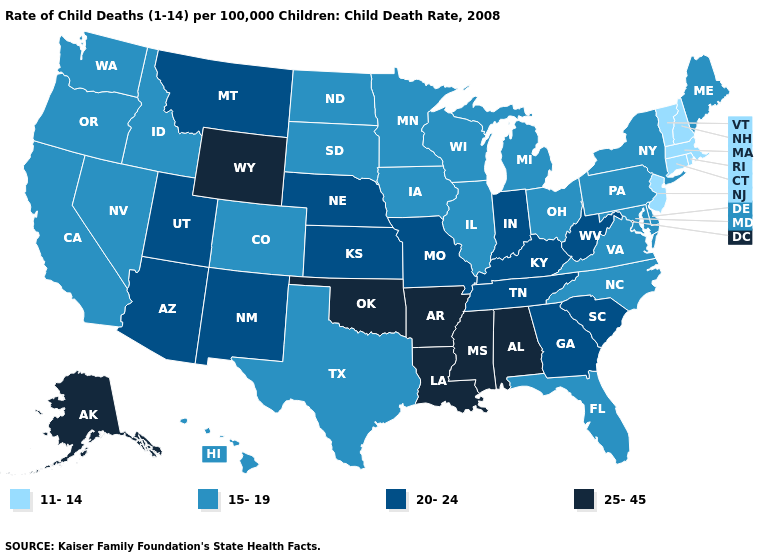Name the states that have a value in the range 15-19?
Keep it brief. California, Colorado, Delaware, Florida, Hawaii, Idaho, Illinois, Iowa, Maine, Maryland, Michigan, Minnesota, Nevada, New York, North Carolina, North Dakota, Ohio, Oregon, Pennsylvania, South Dakota, Texas, Virginia, Washington, Wisconsin. Which states have the lowest value in the South?
Short answer required. Delaware, Florida, Maryland, North Carolina, Texas, Virginia. Name the states that have a value in the range 20-24?
Keep it brief. Arizona, Georgia, Indiana, Kansas, Kentucky, Missouri, Montana, Nebraska, New Mexico, South Carolina, Tennessee, Utah, West Virginia. What is the lowest value in the MidWest?
Answer briefly. 15-19. What is the value of Mississippi?
Concise answer only. 25-45. Is the legend a continuous bar?
Be succinct. No. Does Arkansas have a lower value than Utah?
Concise answer only. No. Among the states that border Ohio , which have the lowest value?
Keep it brief. Michigan, Pennsylvania. Which states have the lowest value in the USA?
Short answer required. Connecticut, Massachusetts, New Hampshire, New Jersey, Rhode Island, Vermont. Among the states that border Montana , which have the highest value?
Concise answer only. Wyoming. What is the highest value in the USA?
Keep it brief. 25-45. Does Louisiana have the same value as Alaska?
Give a very brief answer. Yes. What is the value of Michigan?
Write a very short answer. 15-19. Name the states that have a value in the range 25-45?
Short answer required. Alabama, Alaska, Arkansas, Louisiana, Mississippi, Oklahoma, Wyoming. Name the states that have a value in the range 25-45?
Quick response, please. Alabama, Alaska, Arkansas, Louisiana, Mississippi, Oklahoma, Wyoming. 